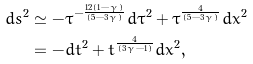Convert formula to latex. <formula><loc_0><loc_0><loc_500><loc_500>d s ^ { 2 } & \simeq - \tau ^ { - \frac { 1 2 ( 1 - \gamma ) } { ( 5 - 3 \gamma ) } } d \tau ^ { 2 } + \tau ^ { \frac { 4 } { ( 5 - 3 \gamma ) } } d x ^ { 2 } \\ & = - d t ^ { 2 } + t ^ { \frac { 4 } { ( 3 \gamma - 1 ) } } d x ^ { 2 } ,</formula> 